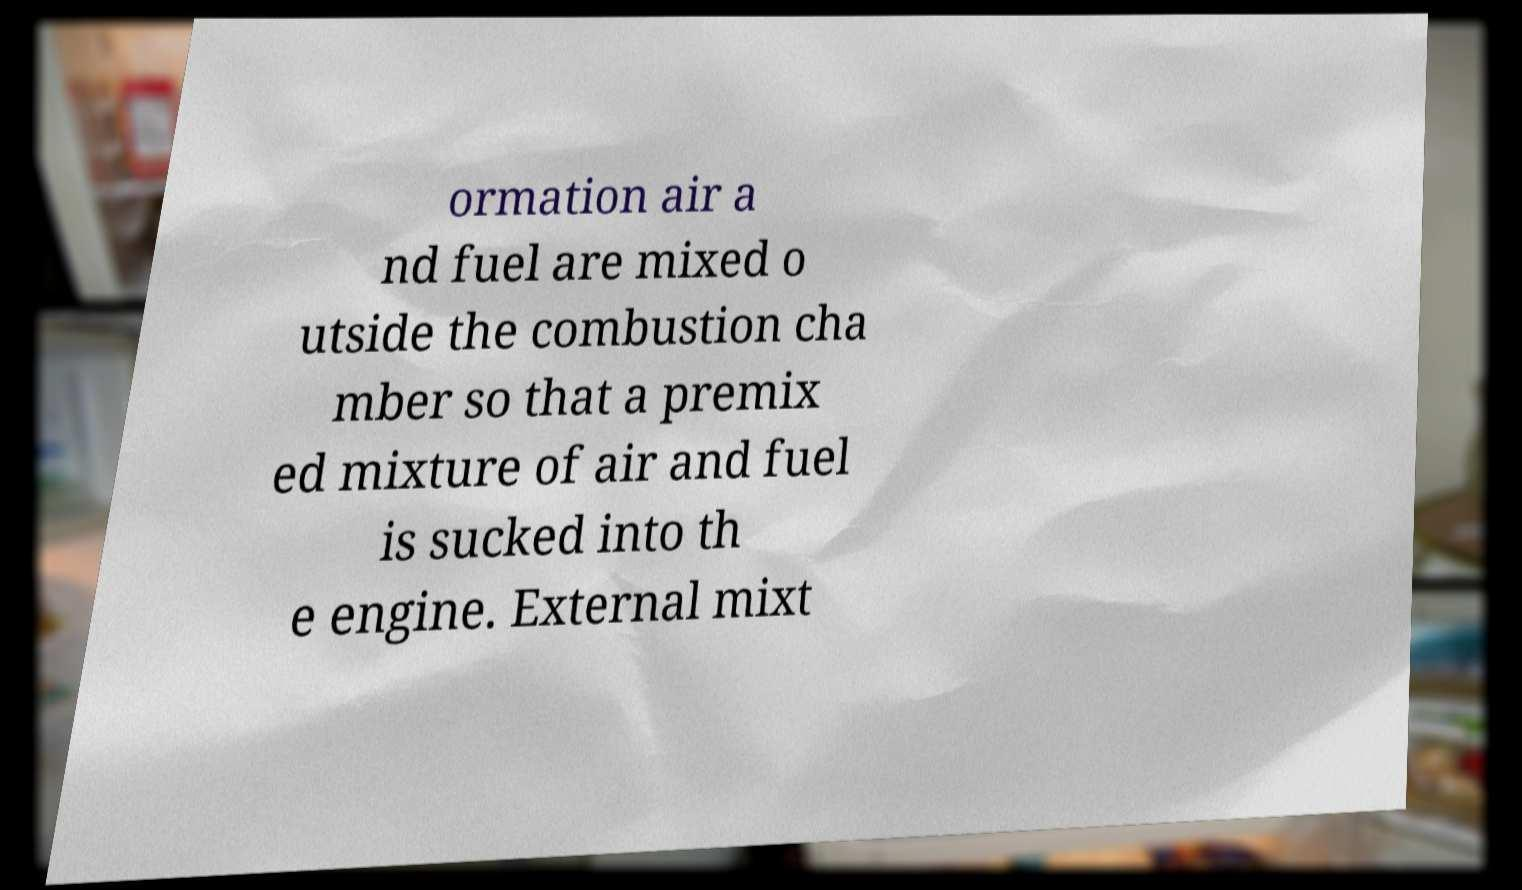I need the written content from this picture converted into text. Can you do that? ormation air a nd fuel are mixed o utside the combustion cha mber so that a premix ed mixture of air and fuel is sucked into th e engine. External mixt 